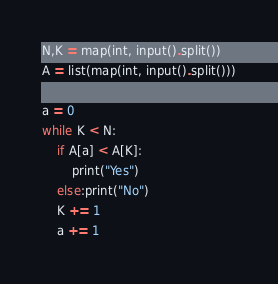Convert code to text. <code><loc_0><loc_0><loc_500><loc_500><_Python_>N,K = map(int, input().split())
A = list(map(int, input().split()))

a = 0
while K < N:
    if A[a] < A[K]:
        print("Yes")
    else:print("No")
    K += 1
    a += 1</code> 